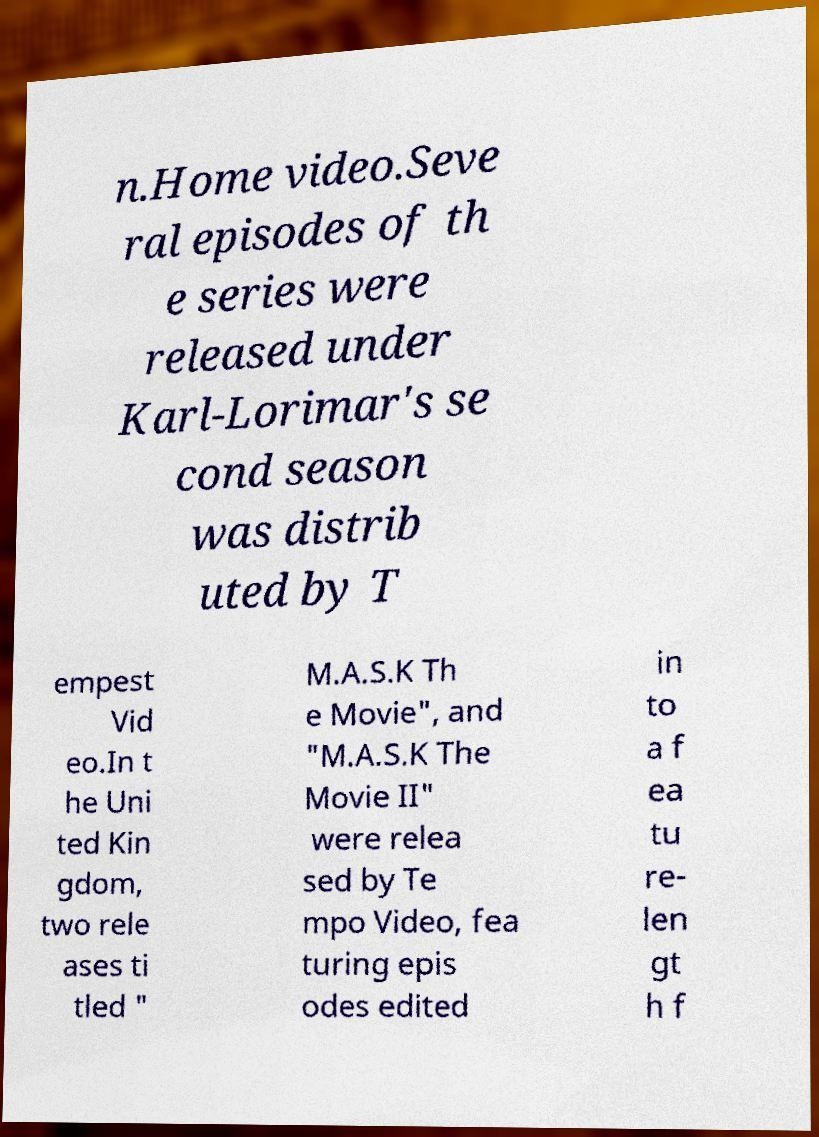Could you extract and type out the text from this image? n.Home video.Seve ral episodes of th e series were released under Karl-Lorimar's se cond season was distrib uted by T empest Vid eo.In t he Uni ted Kin gdom, two rele ases ti tled " M.A.S.K Th e Movie", and "M.A.S.K The Movie II" were relea sed by Te mpo Video, fea turing epis odes edited in to a f ea tu re- len gt h f 